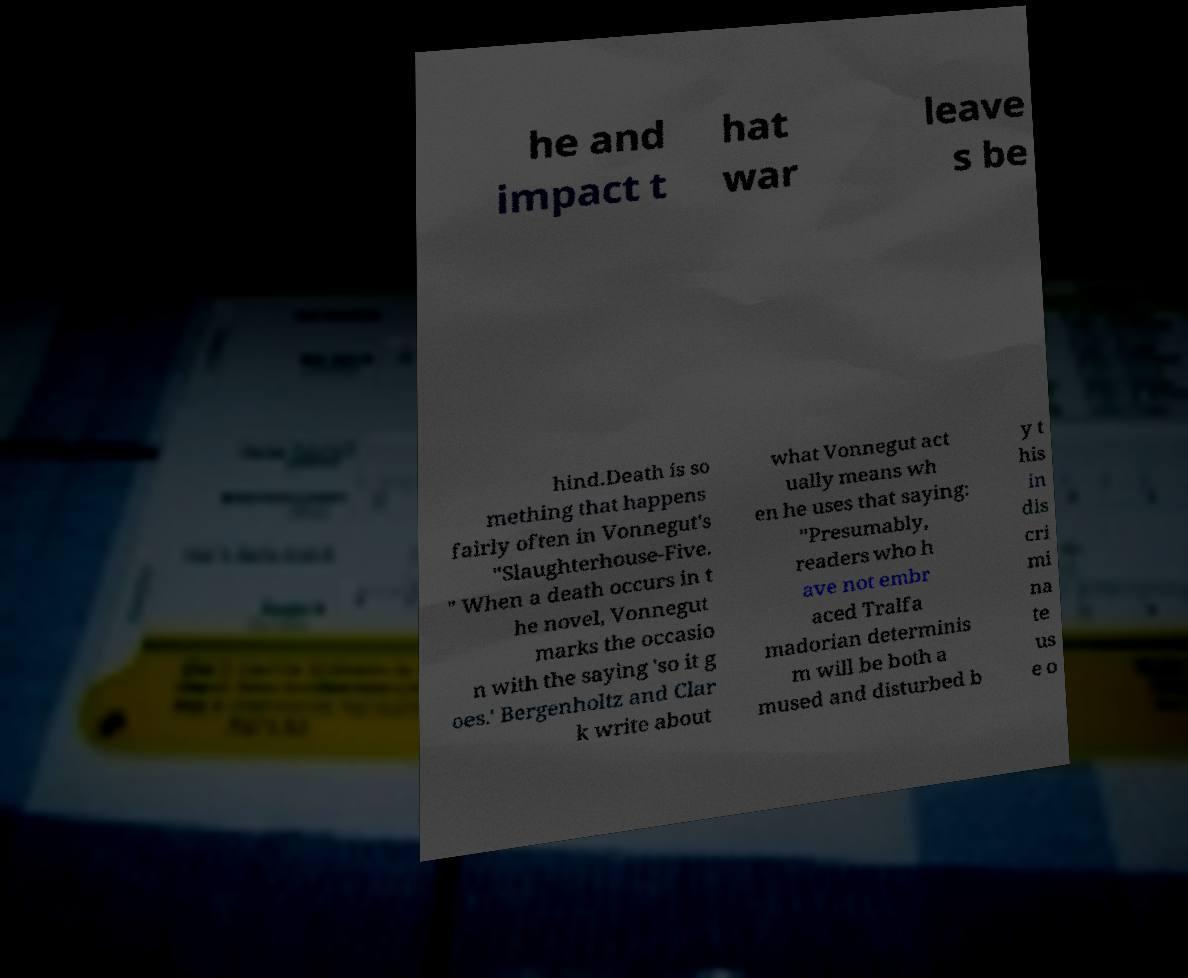What messages or text are displayed in this image? I need them in a readable, typed format. he and impact t hat war leave s be hind.Death is so mething that happens fairly often in Vonnegut's "Slaughterhouse-Five. " When a death occurs in t he novel, Vonnegut marks the occasio n with the saying 'so it g oes.' Bergenholtz and Clar k write about what Vonnegut act ually means wh en he uses that saying: "Presumably, readers who h ave not embr aced Tralfa madorian determinis m will be both a mused and disturbed b y t his in dis cri mi na te us e o 